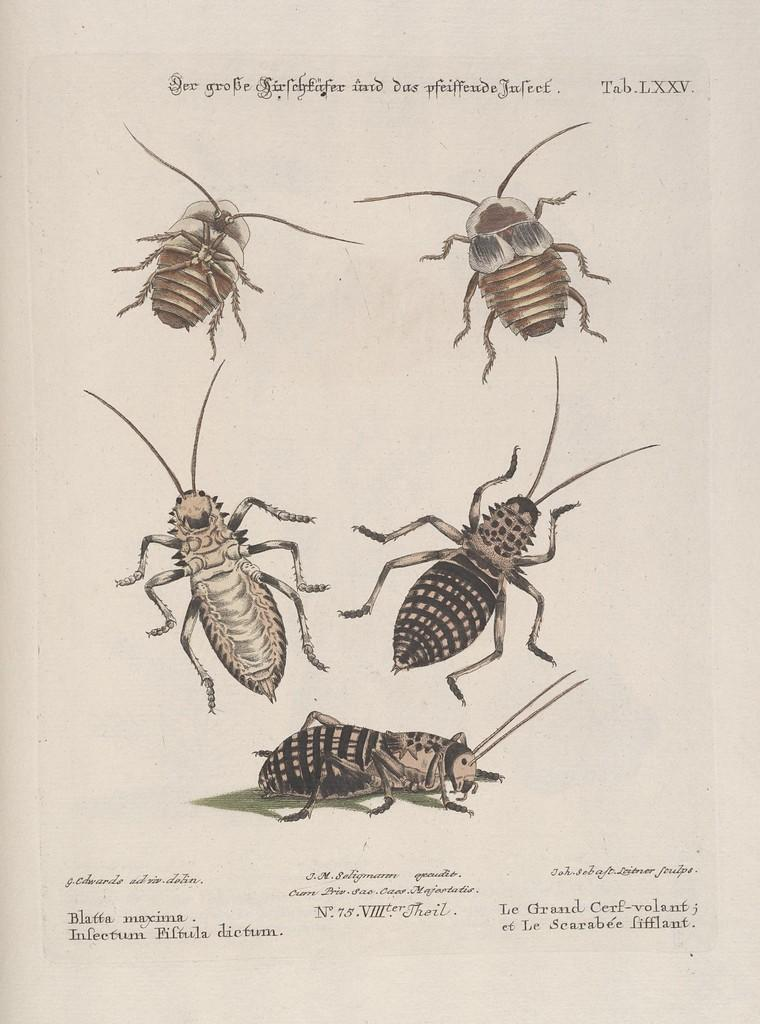What type of visual is the image? The image is a poster. What is depicted in the poster? There is a depiction of cockroaches in the image. Where can text be found on the poster? There is text written on the top and bottom of the image. How many clocks are shown in the image? There are no clocks present in the image; it features a depiction of cockroaches and text. 